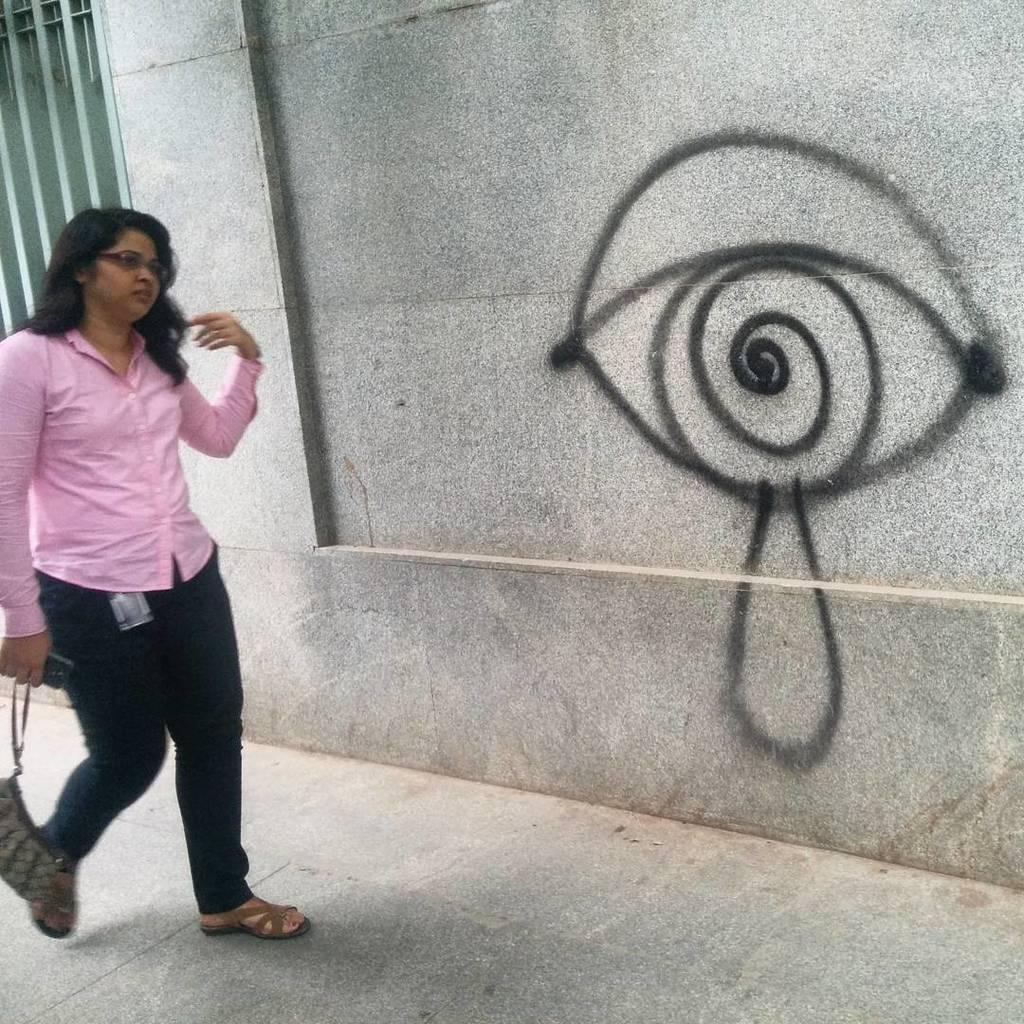Who is present in the image? There is a woman in the image. What is the woman doing? The woman is walking. What items is the woman holding? The woman is holding a purse and a mobile phone. What can be seen in the background of the image? There is a drawing on the wall in the background of the image. How many birds are flying in the image? A: There are no birds present in the image. 